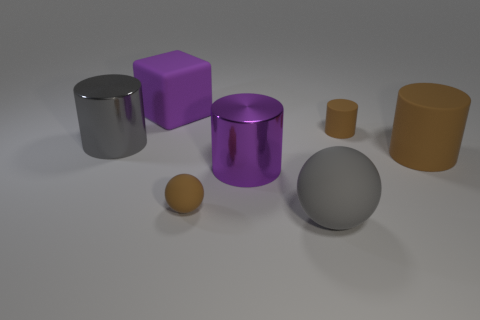What is the shape of the metal thing that is the same color as the block?
Ensure brevity in your answer.  Cylinder. What number of purple rubber things are to the right of the large brown rubber object?
Your answer should be very brief. 0. Does the big brown rubber object have the same shape as the gray metallic object?
Provide a short and direct response. Yes. What number of metallic things are both to the left of the rubber block and to the right of the gray cylinder?
Give a very brief answer. 0. How many objects are either gray metallic things or tiny brown matte things on the right side of the big gray matte thing?
Make the answer very short. 2. Is the number of purple blocks greater than the number of small purple metallic cubes?
Provide a short and direct response. Yes. What shape is the large purple thing in front of the large gray cylinder?
Your answer should be very brief. Cylinder. What number of small yellow matte things have the same shape as the gray rubber object?
Your answer should be compact. 0. There is a brown cylinder that is behind the large gray thing behind the brown ball; how big is it?
Your answer should be very brief. Small. What number of purple objects are either matte spheres or large rubber objects?
Ensure brevity in your answer.  1. 